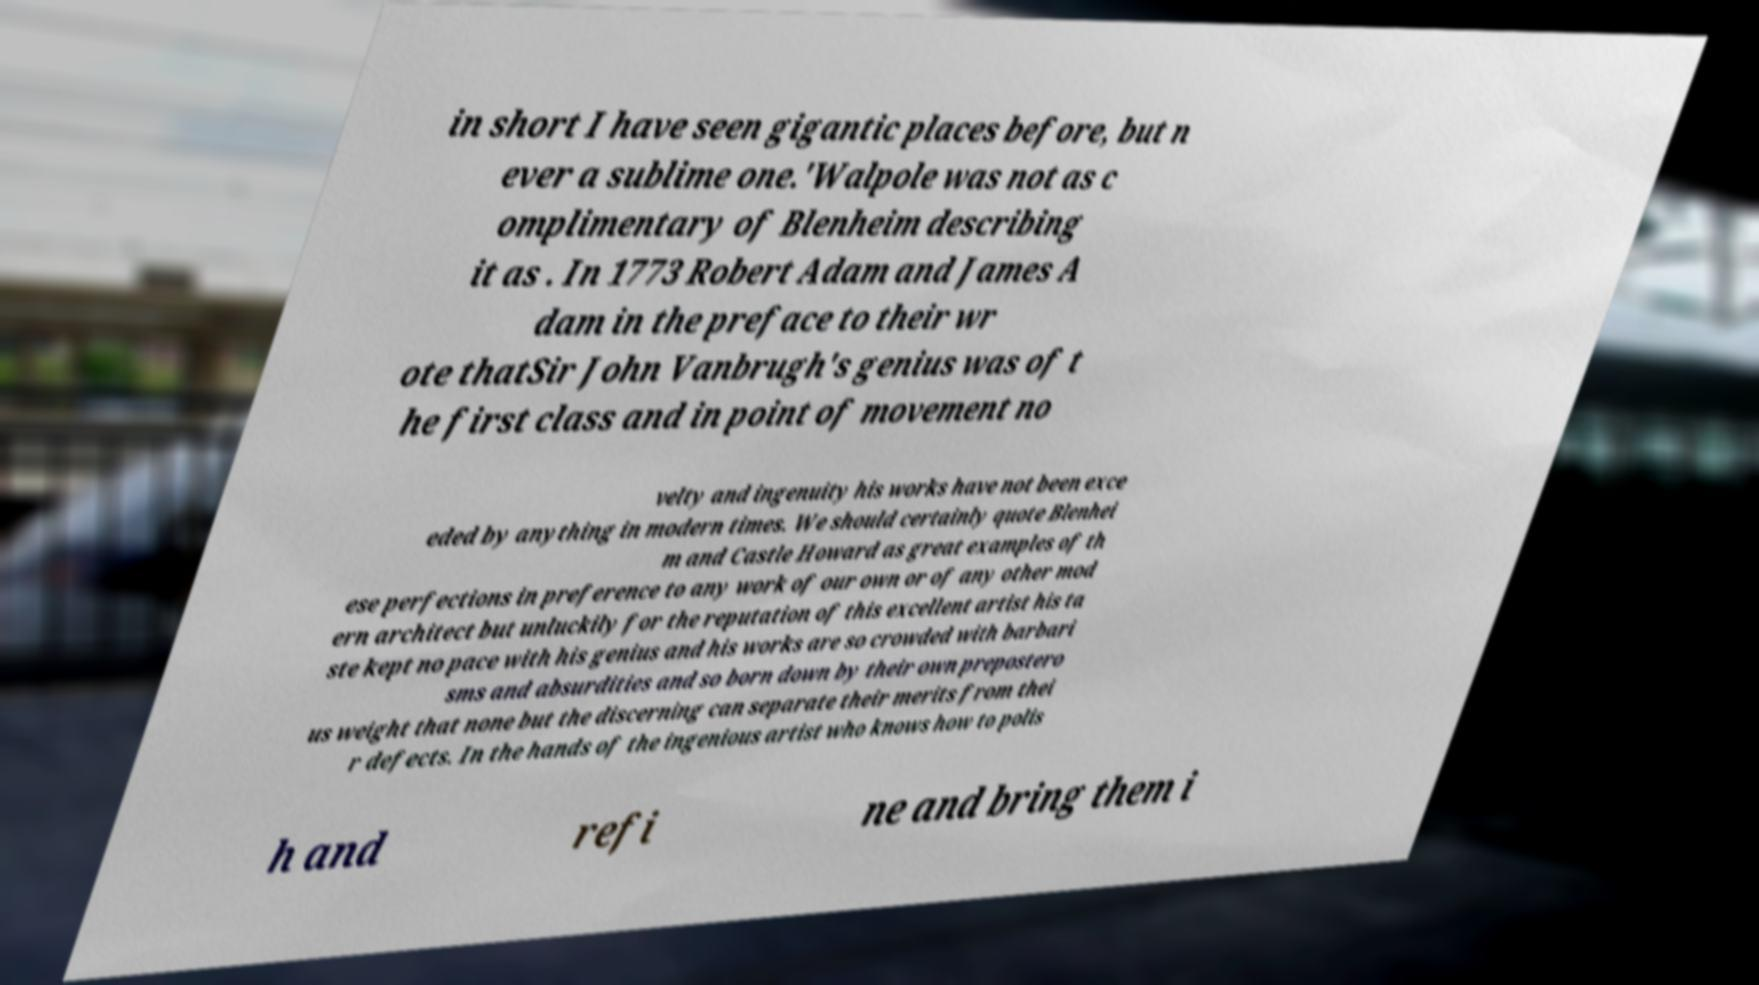Could you extract and type out the text from this image? in short I have seen gigantic places before, but n ever a sublime one.'Walpole was not as c omplimentary of Blenheim describing it as . In 1773 Robert Adam and James A dam in the preface to their wr ote thatSir John Vanbrugh's genius was of t he first class and in point of movement no velty and ingenuity his works have not been exce eded by anything in modern times. We should certainly quote Blenhei m and Castle Howard as great examples of th ese perfections in preference to any work of our own or of any other mod ern architect but unluckily for the reputation of this excellent artist his ta ste kept no pace with his genius and his works are so crowded with barbari sms and absurdities and so born down by their own prepostero us weight that none but the discerning can separate their merits from thei r defects. In the hands of the ingenious artist who knows how to polis h and refi ne and bring them i 